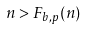<formula> <loc_0><loc_0><loc_500><loc_500>n > F _ { b , p } ( n )</formula> 